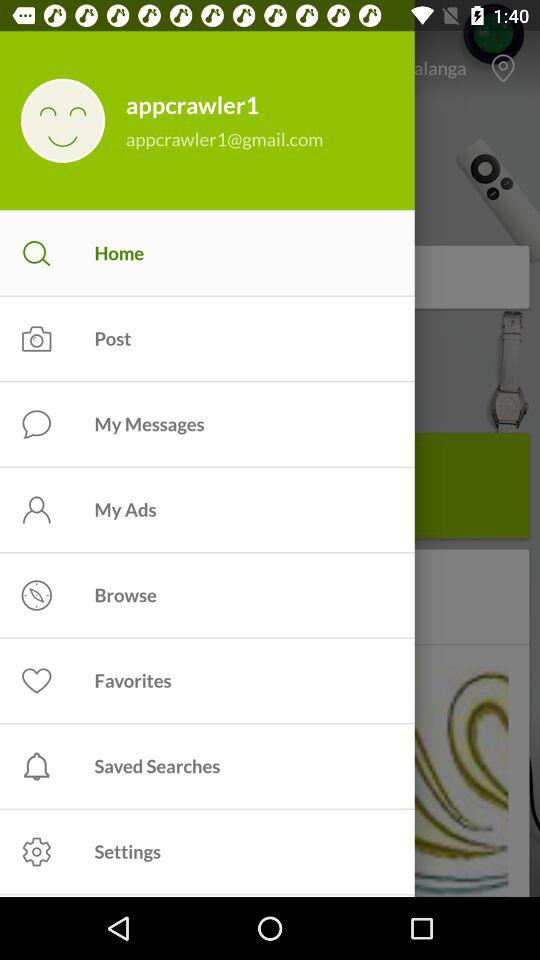What's the user profile name? The user profile name is "appcrawler1". 